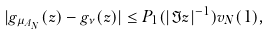Convert formula to latex. <formula><loc_0><loc_0><loc_500><loc_500>| g _ { \mu _ { A _ { N } } } ( z ) - g _ { \nu } ( z ) | \leq P _ { 1 } ( | \Im z | ^ { - 1 } ) v _ { N } ( 1 ) ,</formula> 